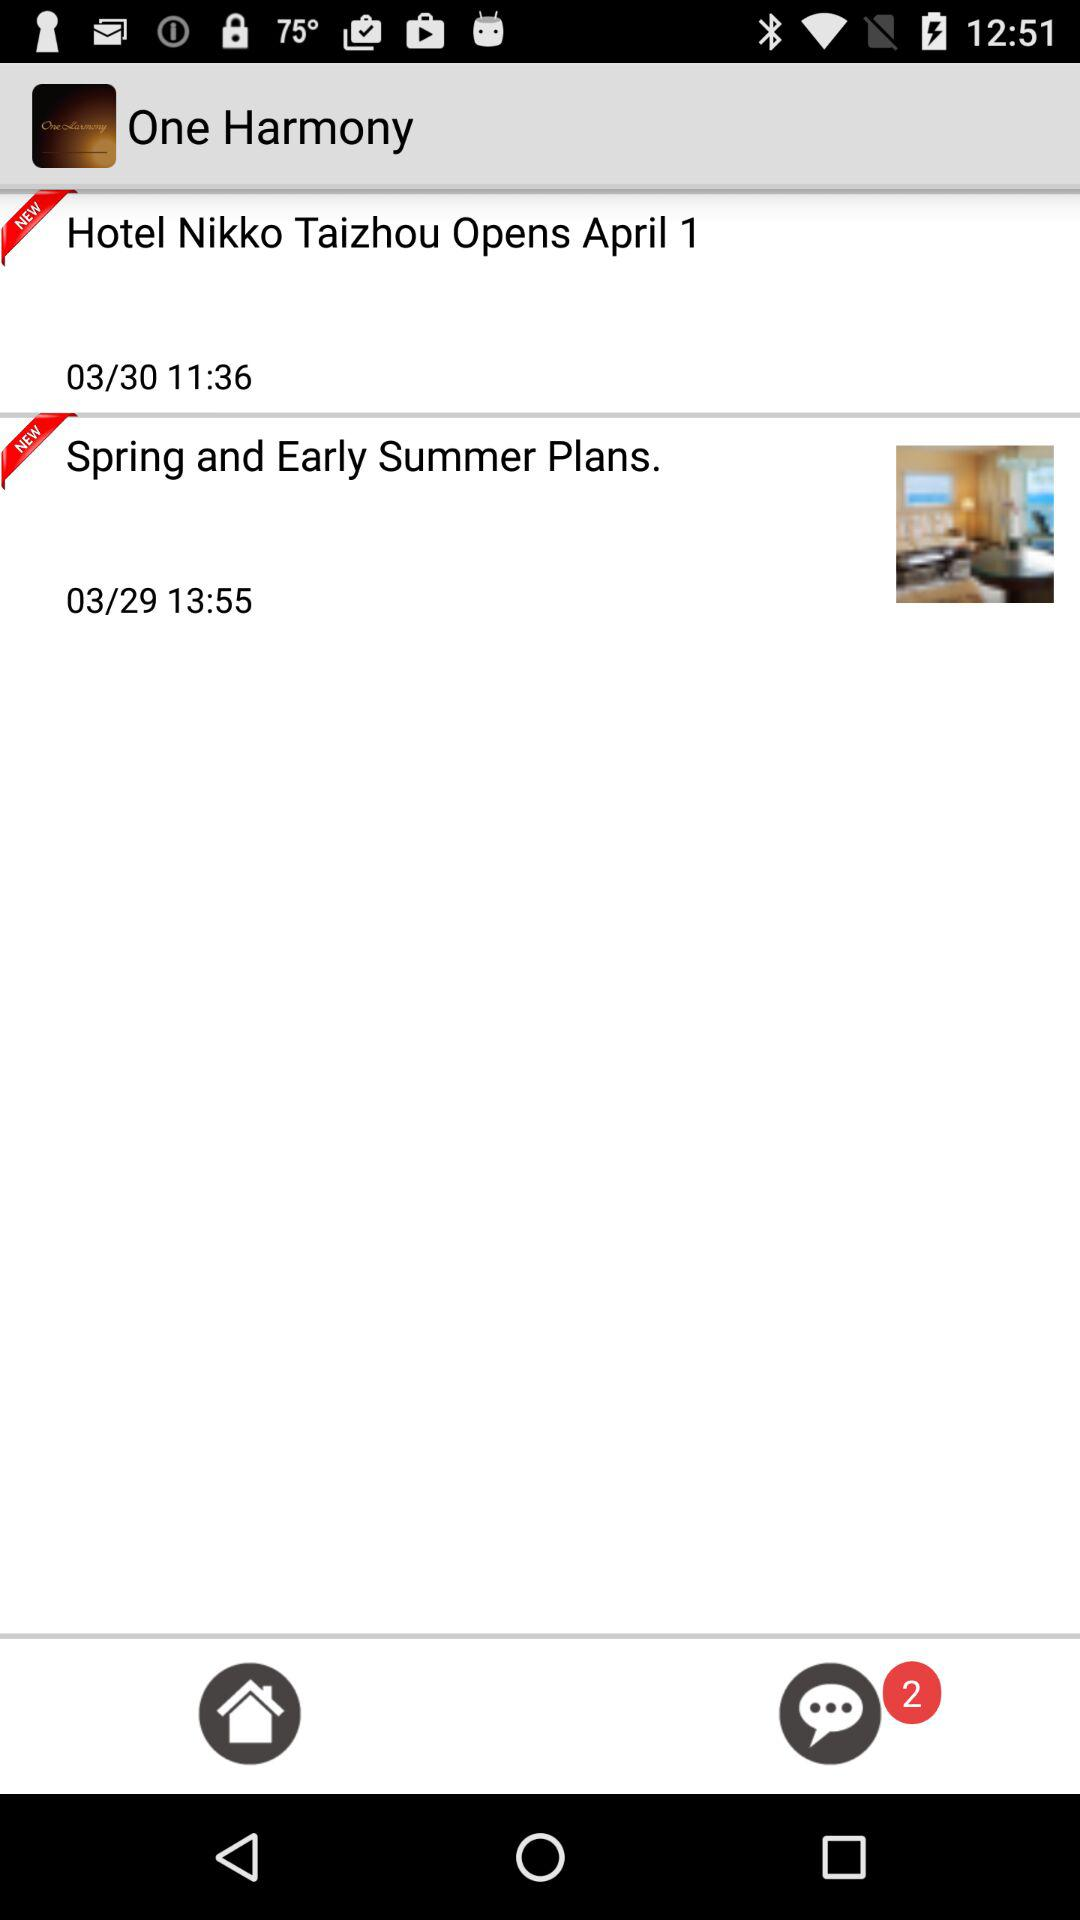What is the posting time for spring and early summer plans? The posting time is 13:55. 